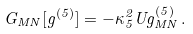Convert formula to latex. <formula><loc_0><loc_0><loc_500><loc_500>G _ { M N } [ g ^ { ( 5 ) } ] = - \kappa _ { 5 } ^ { 2 } U g _ { M N } ^ { ( 5 ) } \, .</formula> 